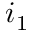Convert formula to latex. <formula><loc_0><loc_0><loc_500><loc_500>i _ { 1 }</formula> 